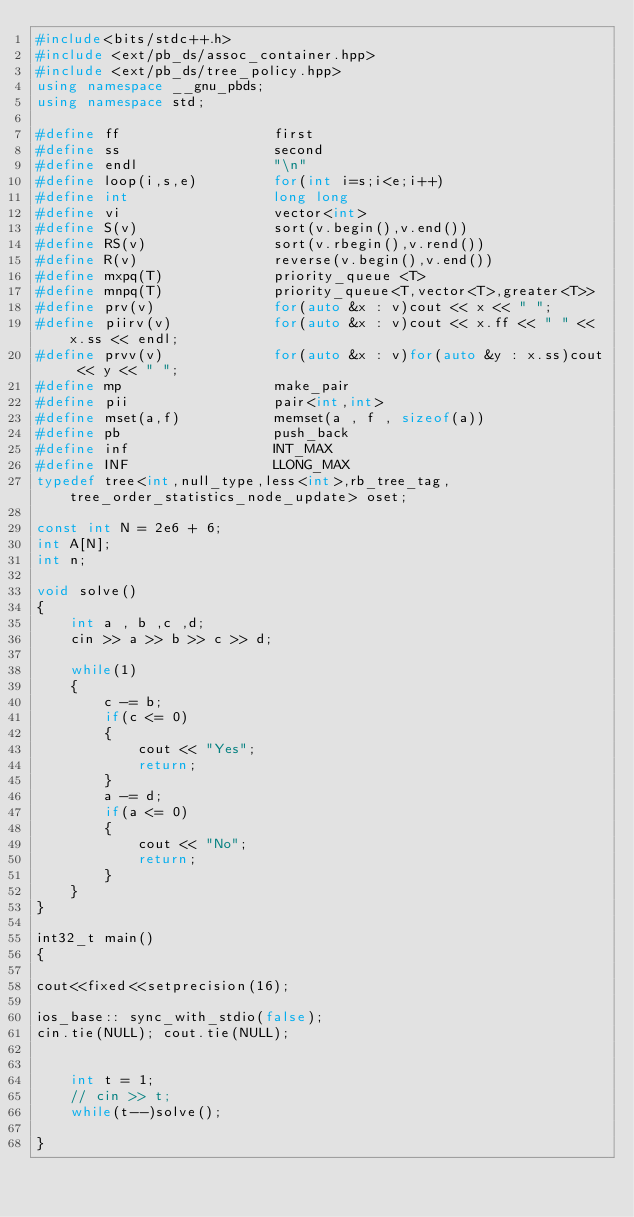Convert code to text. <code><loc_0><loc_0><loc_500><loc_500><_C++_>#include<bits/stdc++.h>
#include <ext/pb_ds/assoc_container.hpp> 
#include <ext/pb_ds/tree_policy.hpp> 
using namespace __gnu_pbds;
using namespace std;
 
#define ff                  first
#define ss                  second
#define endl                "\n"
#define loop(i,s,e)         for(int i=s;i<e;i++)
#define int                 long long
#define vi                  vector<int> 
#define S(v)                sort(v.begin(),v.end())
#define RS(v)               sort(v.rbegin(),v.rend())
#define R(v)                reverse(v.begin(),v.end())
#define mxpq(T)             priority_queue <T>
#define mnpq(T)             priority_queue<T,vector<T>,greater<T>>
#define prv(v)              for(auto &x : v)cout << x << " ";
#define piirv(v)            for(auto &x : v)cout << x.ff << " " << x.ss << endl;
#define prvv(v)             for(auto &x : v)for(auto &y : x.ss)cout << y << " ";
#define mp                  make_pair
#define pii                 pair<int,int>
#define mset(a,f)           memset(a , f , sizeof(a))
#define pb                  push_back
#define inf                 INT_MAX
#define INF                 LLONG_MAX
typedef tree<int,null_type,less<int>,rb_tree_tag,tree_order_statistics_node_update> oset;

const int N = 2e6 + 6;
int A[N];
int n;

void solve()
{
	int a , b ,c ,d;
	cin >> a >> b >> c >> d;
	
	while(1)
	{
		c -= b;
		if(c <= 0)
		{
			cout << "Yes";
			return;
		}
		a -= d;
		if(a <= 0)
		{
			cout << "No";
			return;
		}
	}
}
 
int32_t main()
{
 
cout<<fixed<<setprecision(16);

ios_base:: sync_with_stdio(false);
cin.tie(NULL); cout.tie(NULL);
 	

 	int t = 1;
 	// cin >> t;
 	while(t--)solve();
  
}</code> 